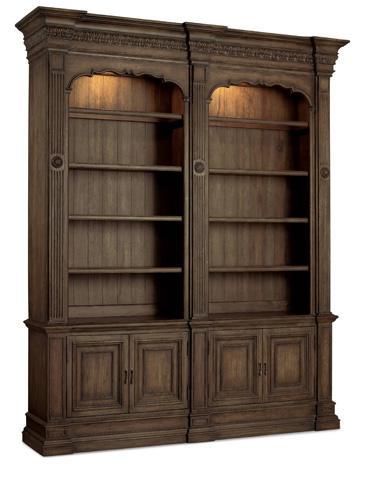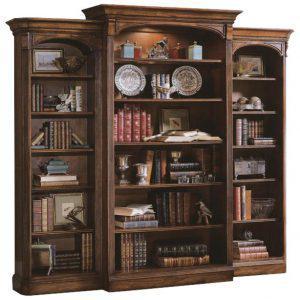The first image is the image on the left, the second image is the image on the right. Given the left and right images, does the statement "In one of the images there is a bookshelf with books on it." hold true? Answer yes or no. Yes. 